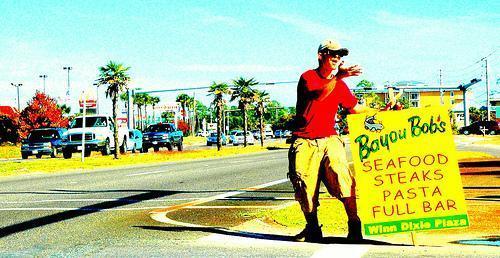How many light posts do you see to the man's left?
Give a very brief answer. 3. 